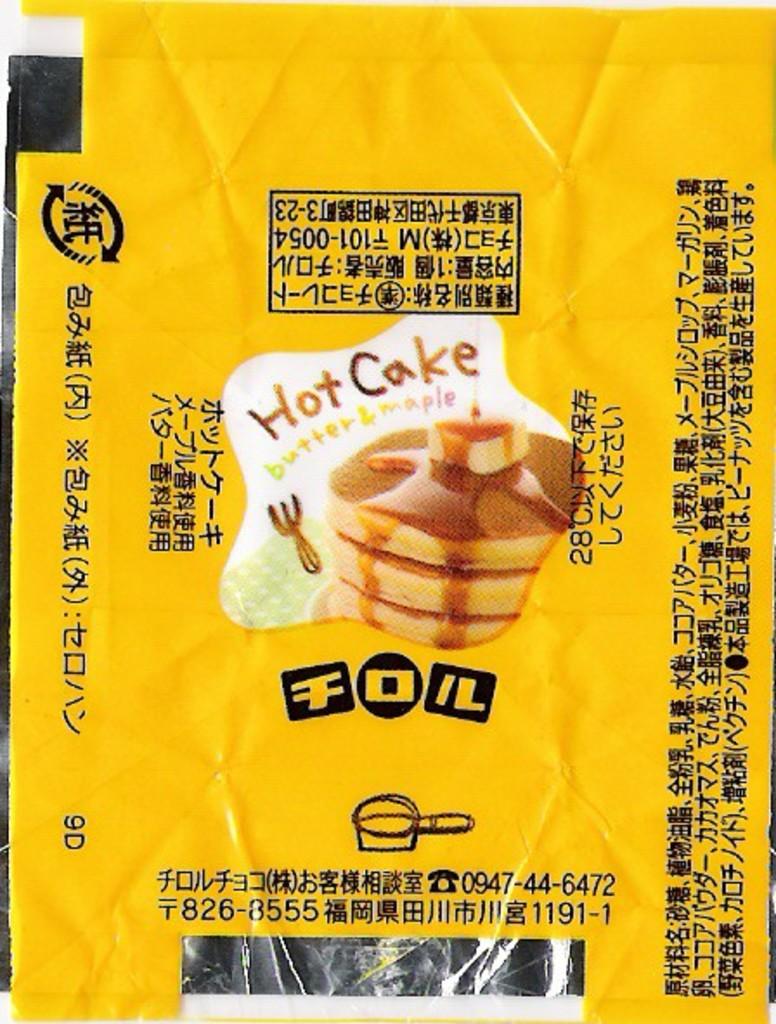What kind of cake is it?
Your answer should be very brief. Hot cake. 